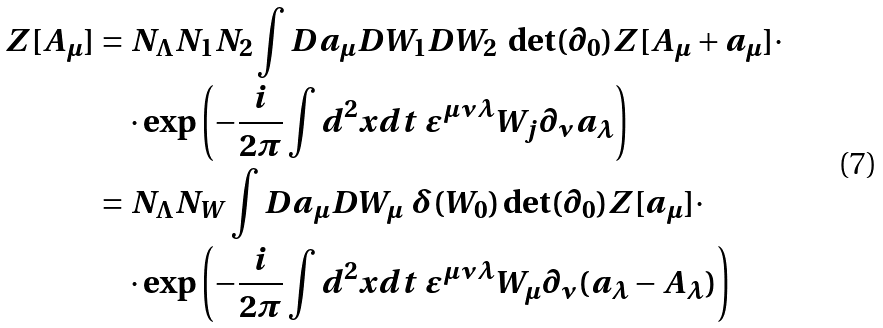<formula> <loc_0><loc_0><loc_500><loc_500>Z [ A _ { \mu } ] & = N _ { \Lambda } N _ { 1 } N _ { 2 } \int D a _ { \mu } D W _ { 1 } D W _ { 2 } \ \det ( \partial _ { 0 } ) Z [ A _ { \mu } + a _ { \mu } ] \cdot \\ & \quad \cdot \exp { \left ( - \frac { i } { 2 \pi } \int d ^ { 2 } x d t \ \varepsilon ^ { \mu \nu \lambda } W _ { j } \partial _ { \nu } a _ { \lambda } \right ) } \\ & = N _ { \Lambda } N _ { W } \int D a _ { \mu } D W _ { \mu } \ \delta ( W _ { 0 } ) \det ( \partial _ { 0 } ) Z [ a _ { \mu } ] \cdot \\ & \quad \cdot \exp { \left ( - \frac { i } { 2 \pi } \int d ^ { 2 } x d t \ \varepsilon ^ { \mu \nu \lambda } W _ { \mu } \partial _ { \nu } ( a _ { \lambda } - A _ { \lambda } ) \right ) }</formula> 